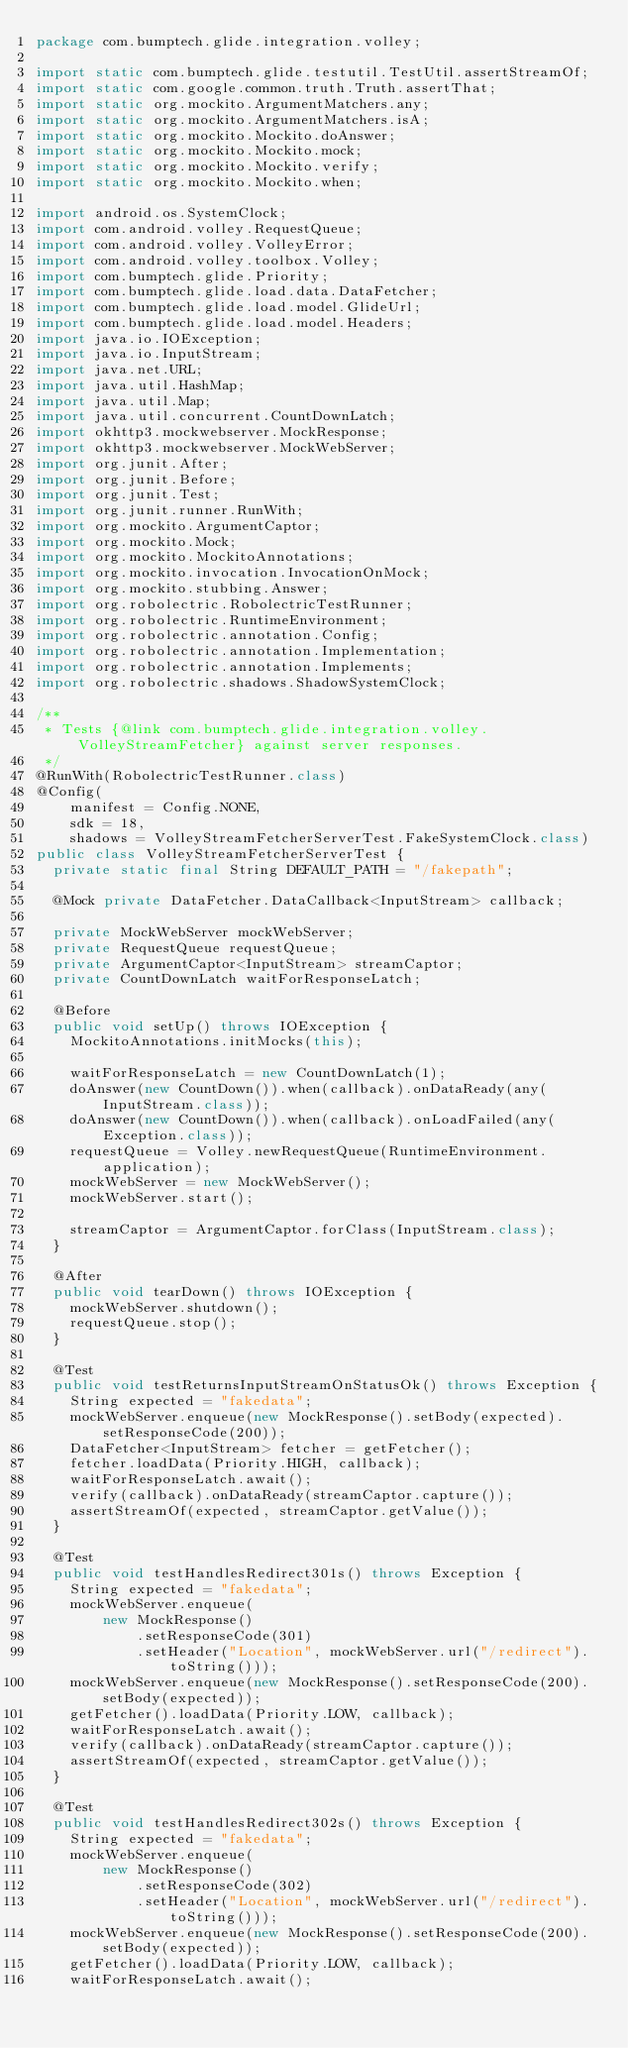Convert code to text. <code><loc_0><loc_0><loc_500><loc_500><_Java_>package com.bumptech.glide.integration.volley;

import static com.bumptech.glide.testutil.TestUtil.assertStreamOf;
import static com.google.common.truth.Truth.assertThat;
import static org.mockito.ArgumentMatchers.any;
import static org.mockito.ArgumentMatchers.isA;
import static org.mockito.Mockito.doAnswer;
import static org.mockito.Mockito.mock;
import static org.mockito.Mockito.verify;
import static org.mockito.Mockito.when;

import android.os.SystemClock;
import com.android.volley.RequestQueue;
import com.android.volley.VolleyError;
import com.android.volley.toolbox.Volley;
import com.bumptech.glide.Priority;
import com.bumptech.glide.load.data.DataFetcher;
import com.bumptech.glide.load.model.GlideUrl;
import com.bumptech.glide.load.model.Headers;
import java.io.IOException;
import java.io.InputStream;
import java.net.URL;
import java.util.HashMap;
import java.util.Map;
import java.util.concurrent.CountDownLatch;
import okhttp3.mockwebserver.MockResponse;
import okhttp3.mockwebserver.MockWebServer;
import org.junit.After;
import org.junit.Before;
import org.junit.Test;
import org.junit.runner.RunWith;
import org.mockito.ArgumentCaptor;
import org.mockito.Mock;
import org.mockito.MockitoAnnotations;
import org.mockito.invocation.InvocationOnMock;
import org.mockito.stubbing.Answer;
import org.robolectric.RobolectricTestRunner;
import org.robolectric.RuntimeEnvironment;
import org.robolectric.annotation.Config;
import org.robolectric.annotation.Implementation;
import org.robolectric.annotation.Implements;
import org.robolectric.shadows.ShadowSystemClock;

/**
 * Tests {@link com.bumptech.glide.integration.volley.VolleyStreamFetcher} against server responses.
 */
@RunWith(RobolectricTestRunner.class)
@Config(
    manifest = Config.NONE,
    sdk = 18,
    shadows = VolleyStreamFetcherServerTest.FakeSystemClock.class)
public class VolleyStreamFetcherServerTest {
  private static final String DEFAULT_PATH = "/fakepath";

  @Mock private DataFetcher.DataCallback<InputStream> callback;

  private MockWebServer mockWebServer;
  private RequestQueue requestQueue;
  private ArgumentCaptor<InputStream> streamCaptor;
  private CountDownLatch waitForResponseLatch;

  @Before
  public void setUp() throws IOException {
    MockitoAnnotations.initMocks(this);

    waitForResponseLatch = new CountDownLatch(1);
    doAnswer(new CountDown()).when(callback).onDataReady(any(InputStream.class));
    doAnswer(new CountDown()).when(callback).onLoadFailed(any(Exception.class));
    requestQueue = Volley.newRequestQueue(RuntimeEnvironment.application);
    mockWebServer = new MockWebServer();
    mockWebServer.start();

    streamCaptor = ArgumentCaptor.forClass(InputStream.class);
  }

  @After
  public void tearDown() throws IOException {
    mockWebServer.shutdown();
    requestQueue.stop();
  }

  @Test
  public void testReturnsInputStreamOnStatusOk() throws Exception {
    String expected = "fakedata";
    mockWebServer.enqueue(new MockResponse().setBody(expected).setResponseCode(200));
    DataFetcher<InputStream> fetcher = getFetcher();
    fetcher.loadData(Priority.HIGH, callback);
    waitForResponseLatch.await();
    verify(callback).onDataReady(streamCaptor.capture());
    assertStreamOf(expected, streamCaptor.getValue());
  }

  @Test
  public void testHandlesRedirect301s() throws Exception {
    String expected = "fakedata";
    mockWebServer.enqueue(
        new MockResponse()
            .setResponseCode(301)
            .setHeader("Location", mockWebServer.url("/redirect").toString()));
    mockWebServer.enqueue(new MockResponse().setResponseCode(200).setBody(expected));
    getFetcher().loadData(Priority.LOW, callback);
    waitForResponseLatch.await();
    verify(callback).onDataReady(streamCaptor.capture());
    assertStreamOf(expected, streamCaptor.getValue());
  }

  @Test
  public void testHandlesRedirect302s() throws Exception {
    String expected = "fakedata";
    mockWebServer.enqueue(
        new MockResponse()
            .setResponseCode(302)
            .setHeader("Location", mockWebServer.url("/redirect").toString()));
    mockWebServer.enqueue(new MockResponse().setResponseCode(200).setBody(expected));
    getFetcher().loadData(Priority.LOW, callback);
    waitForResponseLatch.await();</code> 